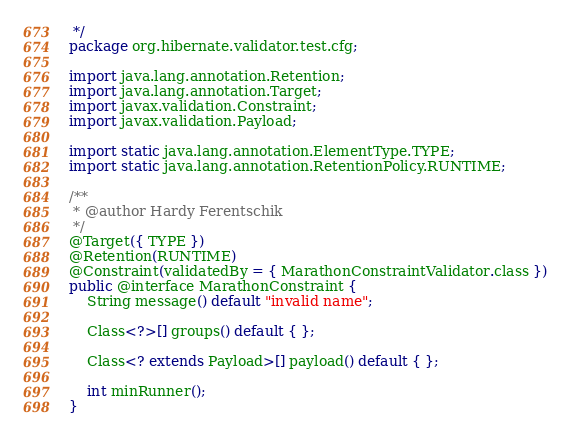Convert code to text. <code><loc_0><loc_0><loc_500><loc_500><_Java_> */
package org.hibernate.validator.test.cfg;

import java.lang.annotation.Retention;
import java.lang.annotation.Target;
import javax.validation.Constraint;
import javax.validation.Payload;

import static java.lang.annotation.ElementType.TYPE;
import static java.lang.annotation.RetentionPolicy.RUNTIME;

/**
 * @author Hardy Ferentschik
 */
@Target({ TYPE })
@Retention(RUNTIME)
@Constraint(validatedBy = { MarathonConstraintValidator.class })
public @interface MarathonConstraint {
	String message() default "invalid name";

	Class<?>[] groups() default { };

	Class<? extends Payload>[] payload() default { };

	int minRunner();
}


</code> 